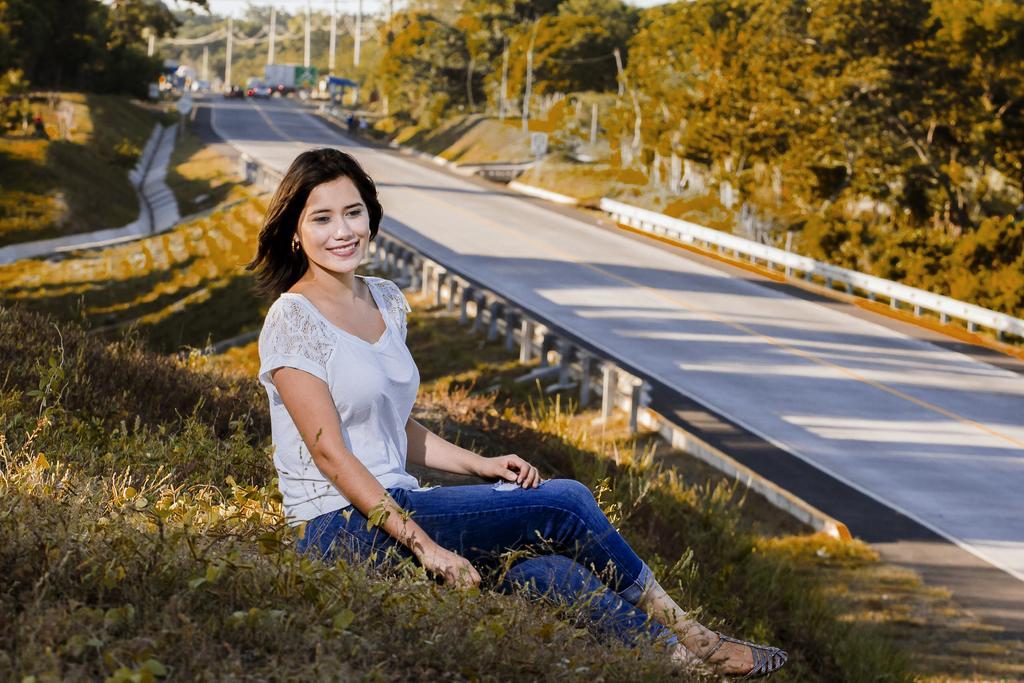Describe this image in one or two sentences. In this picture there is a woman with white top is sitting. At the back there are vehicles on the road and there are trees and poles. At the top there is sky. At the bottom there is a road and there are railings and there is grass. 